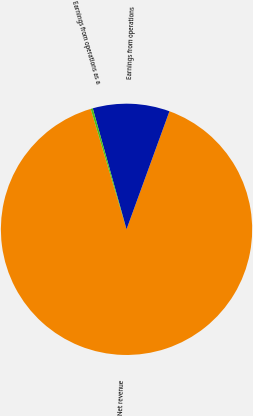Convert chart. <chart><loc_0><loc_0><loc_500><loc_500><pie_chart><fcel>Net revenue<fcel>Earnings from operations<fcel>Earnings from operations as a<nl><fcel>89.85%<fcel>9.88%<fcel>0.27%<nl></chart> 